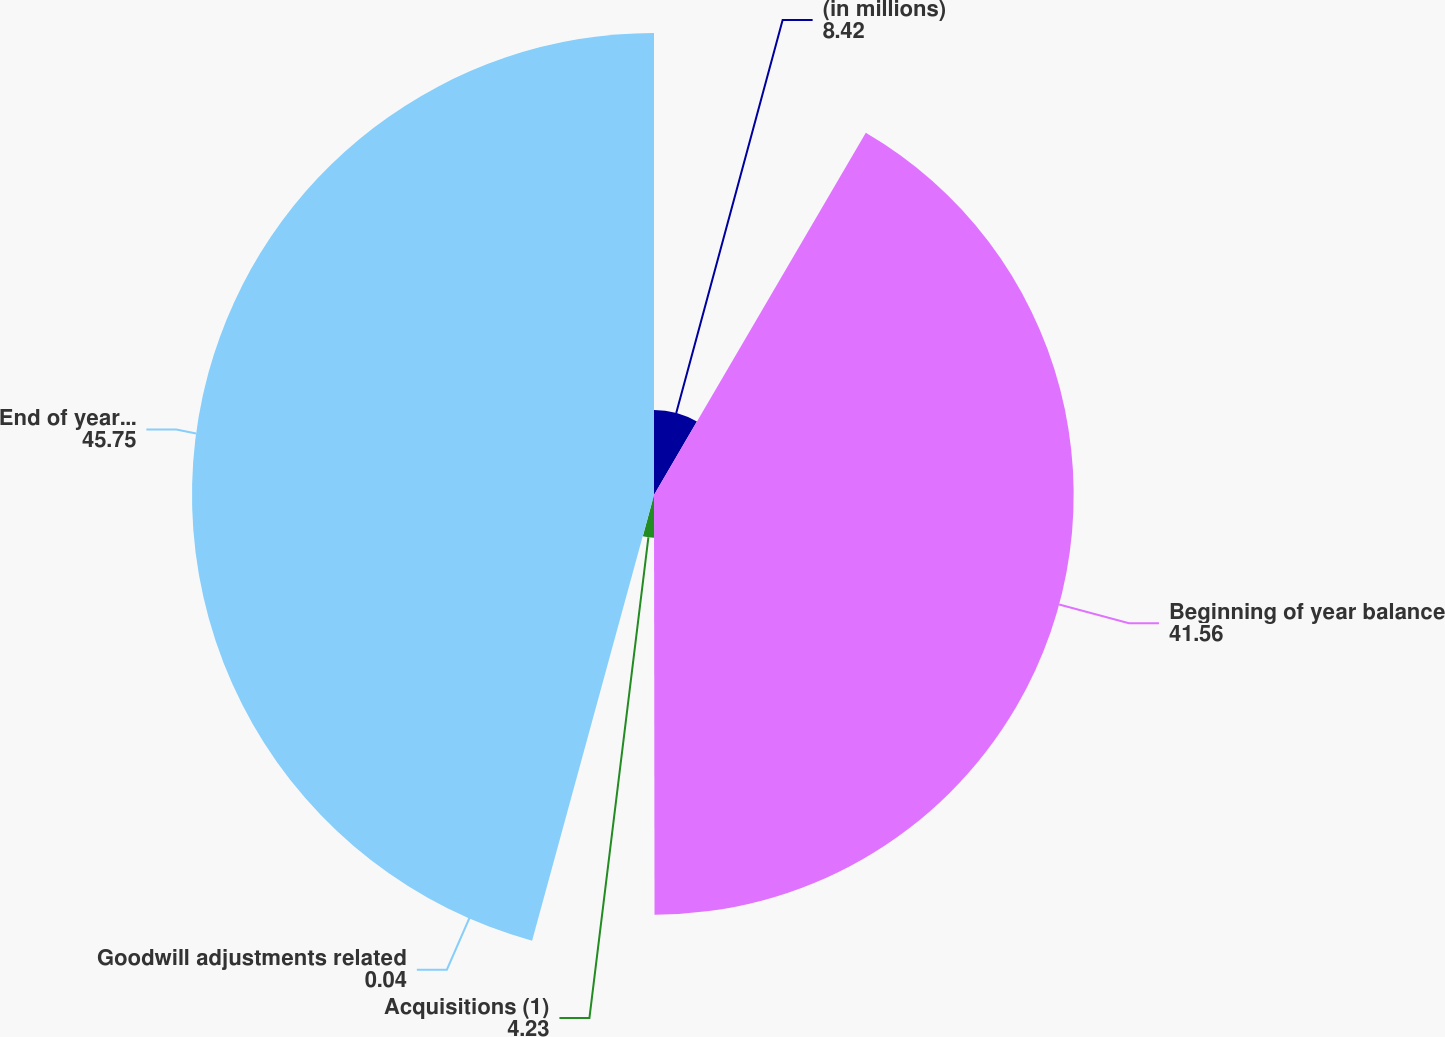<chart> <loc_0><loc_0><loc_500><loc_500><pie_chart><fcel>(in millions)<fcel>Beginning of year balance<fcel>Acquisitions (1)<fcel>Goodwill adjustments related<fcel>End of year balance<nl><fcel>8.42%<fcel>41.56%<fcel>4.23%<fcel>0.04%<fcel>45.75%<nl></chart> 